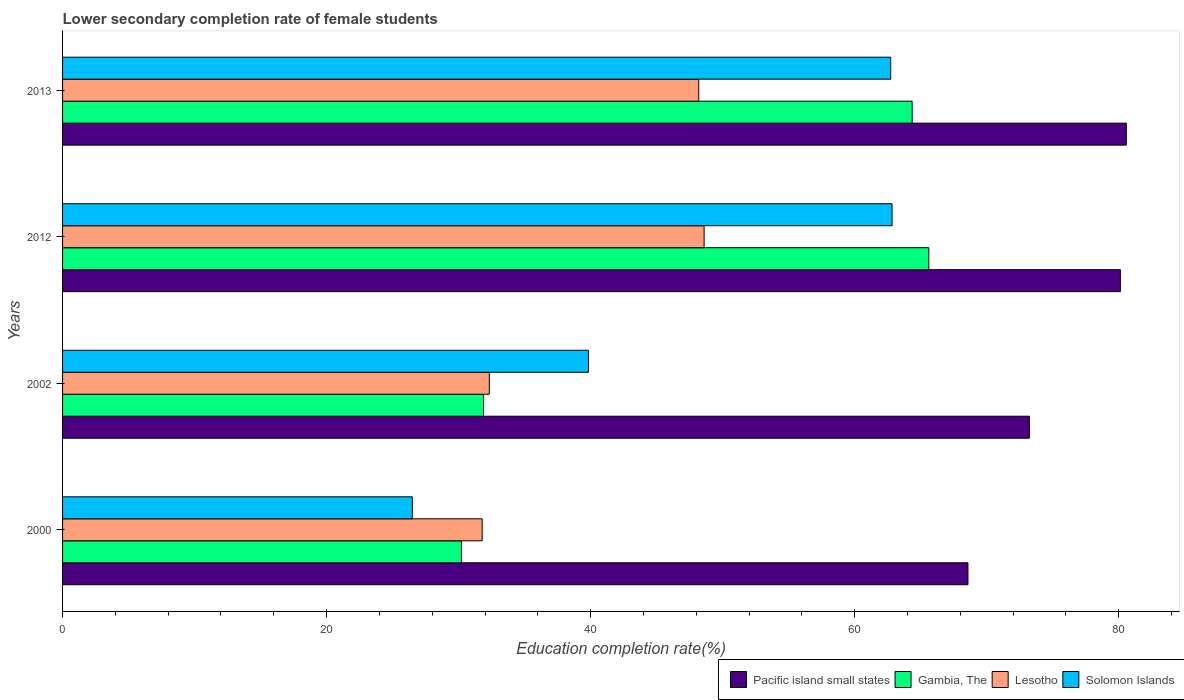How many different coloured bars are there?
Provide a succinct answer. 4. How many groups of bars are there?
Provide a short and direct response. 4. Are the number of bars on each tick of the Y-axis equal?
Offer a very short reply. Yes. How many bars are there on the 3rd tick from the top?
Offer a terse response. 4. How many bars are there on the 1st tick from the bottom?
Your response must be concise. 4. In how many cases, is the number of bars for a given year not equal to the number of legend labels?
Make the answer very short. 0. What is the lower secondary completion rate of female students in Gambia, The in 2012?
Give a very brief answer. 65.62. Across all years, what is the maximum lower secondary completion rate of female students in Pacific island small states?
Ensure brevity in your answer.  80.58. Across all years, what is the minimum lower secondary completion rate of female students in Solomon Islands?
Your answer should be compact. 26.5. In which year was the lower secondary completion rate of female students in Lesotho minimum?
Give a very brief answer. 2000. What is the total lower secondary completion rate of female students in Lesotho in the graph?
Your answer should be very brief. 160.9. What is the difference between the lower secondary completion rate of female students in Lesotho in 2000 and that in 2013?
Offer a very short reply. -16.4. What is the difference between the lower secondary completion rate of female students in Lesotho in 2012 and the lower secondary completion rate of female students in Gambia, The in 2002?
Offer a very short reply. 16.71. What is the average lower secondary completion rate of female students in Gambia, The per year?
Make the answer very short. 48.02. In the year 2012, what is the difference between the lower secondary completion rate of female students in Solomon Islands and lower secondary completion rate of female students in Pacific island small states?
Make the answer very short. -17.3. In how many years, is the lower secondary completion rate of female students in Pacific island small states greater than 56 %?
Offer a very short reply. 4. What is the ratio of the lower secondary completion rate of female students in Lesotho in 2000 to that in 2002?
Give a very brief answer. 0.98. What is the difference between the highest and the second highest lower secondary completion rate of female students in Lesotho?
Offer a terse response. 0.41. What is the difference between the highest and the lowest lower secondary completion rate of female students in Lesotho?
Give a very brief answer. 16.81. Is it the case that in every year, the sum of the lower secondary completion rate of female students in Gambia, The and lower secondary completion rate of female students in Pacific island small states is greater than the sum of lower secondary completion rate of female students in Lesotho and lower secondary completion rate of female students in Solomon Islands?
Keep it short and to the point. No. What does the 1st bar from the top in 2000 represents?
Your answer should be very brief. Solomon Islands. What does the 2nd bar from the bottom in 2013 represents?
Provide a short and direct response. Gambia, The. How many bars are there?
Your answer should be very brief. 16. Are all the bars in the graph horizontal?
Offer a very short reply. Yes. How many years are there in the graph?
Keep it short and to the point. 4. Does the graph contain any zero values?
Provide a short and direct response. No. Does the graph contain grids?
Provide a short and direct response. No. Where does the legend appear in the graph?
Your answer should be very brief. Bottom right. How are the legend labels stacked?
Keep it short and to the point. Horizontal. What is the title of the graph?
Your answer should be compact. Lower secondary completion rate of female students. What is the label or title of the X-axis?
Your response must be concise. Education completion rate(%). What is the label or title of the Y-axis?
Your answer should be very brief. Years. What is the Education completion rate(%) of Pacific island small states in 2000?
Give a very brief answer. 68.58. What is the Education completion rate(%) in Gambia, The in 2000?
Ensure brevity in your answer.  30.21. What is the Education completion rate(%) of Lesotho in 2000?
Provide a succinct answer. 31.79. What is the Education completion rate(%) of Solomon Islands in 2000?
Provide a short and direct response. 26.5. What is the Education completion rate(%) of Pacific island small states in 2002?
Your answer should be very brief. 73.24. What is the Education completion rate(%) in Gambia, The in 2002?
Keep it short and to the point. 31.89. What is the Education completion rate(%) of Lesotho in 2002?
Offer a very short reply. 32.33. What is the Education completion rate(%) in Solomon Islands in 2002?
Offer a very short reply. 39.83. What is the Education completion rate(%) of Pacific island small states in 2012?
Offer a terse response. 80.13. What is the Education completion rate(%) in Gambia, The in 2012?
Give a very brief answer. 65.62. What is the Education completion rate(%) in Lesotho in 2012?
Provide a succinct answer. 48.6. What is the Education completion rate(%) of Solomon Islands in 2012?
Your response must be concise. 62.83. What is the Education completion rate(%) in Pacific island small states in 2013?
Provide a short and direct response. 80.58. What is the Education completion rate(%) in Gambia, The in 2013?
Provide a short and direct response. 64.35. What is the Education completion rate(%) in Lesotho in 2013?
Keep it short and to the point. 48.19. What is the Education completion rate(%) of Solomon Islands in 2013?
Make the answer very short. 62.73. Across all years, what is the maximum Education completion rate(%) in Pacific island small states?
Give a very brief answer. 80.58. Across all years, what is the maximum Education completion rate(%) in Gambia, The?
Your answer should be very brief. 65.62. Across all years, what is the maximum Education completion rate(%) of Lesotho?
Keep it short and to the point. 48.6. Across all years, what is the maximum Education completion rate(%) in Solomon Islands?
Your response must be concise. 62.83. Across all years, what is the minimum Education completion rate(%) in Pacific island small states?
Your answer should be very brief. 68.58. Across all years, what is the minimum Education completion rate(%) in Gambia, The?
Your answer should be compact. 30.21. Across all years, what is the minimum Education completion rate(%) in Lesotho?
Your response must be concise. 31.79. Across all years, what is the minimum Education completion rate(%) of Solomon Islands?
Your response must be concise. 26.5. What is the total Education completion rate(%) of Pacific island small states in the graph?
Your response must be concise. 302.53. What is the total Education completion rate(%) in Gambia, The in the graph?
Give a very brief answer. 192.08. What is the total Education completion rate(%) in Lesotho in the graph?
Ensure brevity in your answer.  160.9. What is the total Education completion rate(%) in Solomon Islands in the graph?
Your answer should be very brief. 191.89. What is the difference between the Education completion rate(%) of Pacific island small states in 2000 and that in 2002?
Your response must be concise. -4.65. What is the difference between the Education completion rate(%) in Gambia, The in 2000 and that in 2002?
Offer a very short reply. -1.68. What is the difference between the Education completion rate(%) of Lesotho in 2000 and that in 2002?
Keep it short and to the point. -0.54. What is the difference between the Education completion rate(%) in Solomon Islands in 2000 and that in 2002?
Give a very brief answer. -13.34. What is the difference between the Education completion rate(%) in Pacific island small states in 2000 and that in 2012?
Keep it short and to the point. -11.54. What is the difference between the Education completion rate(%) of Gambia, The in 2000 and that in 2012?
Keep it short and to the point. -35.4. What is the difference between the Education completion rate(%) in Lesotho in 2000 and that in 2012?
Give a very brief answer. -16.81. What is the difference between the Education completion rate(%) of Solomon Islands in 2000 and that in 2012?
Make the answer very short. -36.34. What is the difference between the Education completion rate(%) of Pacific island small states in 2000 and that in 2013?
Give a very brief answer. -11.99. What is the difference between the Education completion rate(%) in Gambia, The in 2000 and that in 2013?
Make the answer very short. -34.14. What is the difference between the Education completion rate(%) in Lesotho in 2000 and that in 2013?
Ensure brevity in your answer.  -16.4. What is the difference between the Education completion rate(%) in Solomon Islands in 2000 and that in 2013?
Your response must be concise. -36.24. What is the difference between the Education completion rate(%) in Pacific island small states in 2002 and that in 2012?
Make the answer very short. -6.89. What is the difference between the Education completion rate(%) of Gambia, The in 2002 and that in 2012?
Offer a very short reply. -33.73. What is the difference between the Education completion rate(%) in Lesotho in 2002 and that in 2012?
Provide a short and direct response. -16.27. What is the difference between the Education completion rate(%) in Solomon Islands in 2002 and that in 2012?
Ensure brevity in your answer.  -23. What is the difference between the Education completion rate(%) in Pacific island small states in 2002 and that in 2013?
Your answer should be compact. -7.34. What is the difference between the Education completion rate(%) in Gambia, The in 2002 and that in 2013?
Ensure brevity in your answer.  -32.46. What is the difference between the Education completion rate(%) of Lesotho in 2002 and that in 2013?
Give a very brief answer. -15.86. What is the difference between the Education completion rate(%) in Solomon Islands in 2002 and that in 2013?
Your response must be concise. -22.9. What is the difference between the Education completion rate(%) in Pacific island small states in 2012 and that in 2013?
Provide a succinct answer. -0.45. What is the difference between the Education completion rate(%) in Gambia, The in 2012 and that in 2013?
Provide a succinct answer. 1.26. What is the difference between the Education completion rate(%) of Lesotho in 2012 and that in 2013?
Your response must be concise. 0.41. What is the difference between the Education completion rate(%) in Solomon Islands in 2012 and that in 2013?
Ensure brevity in your answer.  0.1. What is the difference between the Education completion rate(%) in Pacific island small states in 2000 and the Education completion rate(%) in Gambia, The in 2002?
Your answer should be compact. 36.69. What is the difference between the Education completion rate(%) in Pacific island small states in 2000 and the Education completion rate(%) in Lesotho in 2002?
Ensure brevity in your answer.  36.26. What is the difference between the Education completion rate(%) of Pacific island small states in 2000 and the Education completion rate(%) of Solomon Islands in 2002?
Provide a short and direct response. 28.75. What is the difference between the Education completion rate(%) of Gambia, The in 2000 and the Education completion rate(%) of Lesotho in 2002?
Give a very brief answer. -2.11. What is the difference between the Education completion rate(%) of Gambia, The in 2000 and the Education completion rate(%) of Solomon Islands in 2002?
Provide a short and direct response. -9.62. What is the difference between the Education completion rate(%) of Lesotho in 2000 and the Education completion rate(%) of Solomon Islands in 2002?
Offer a very short reply. -8.05. What is the difference between the Education completion rate(%) of Pacific island small states in 2000 and the Education completion rate(%) of Gambia, The in 2012?
Provide a succinct answer. 2.97. What is the difference between the Education completion rate(%) of Pacific island small states in 2000 and the Education completion rate(%) of Lesotho in 2012?
Offer a very short reply. 19.99. What is the difference between the Education completion rate(%) of Pacific island small states in 2000 and the Education completion rate(%) of Solomon Islands in 2012?
Keep it short and to the point. 5.75. What is the difference between the Education completion rate(%) of Gambia, The in 2000 and the Education completion rate(%) of Lesotho in 2012?
Offer a terse response. -18.38. What is the difference between the Education completion rate(%) in Gambia, The in 2000 and the Education completion rate(%) in Solomon Islands in 2012?
Keep it short and to the point. -32.62. What is the difference between the Education completion rate(%) in Lesotho in 2000 and the Education completion rate(%) in Solomon Islands in 2012?
Ensure brevity in your answer.  -31.05. What is the difference between the Education completion rate(%) in Pacific island small states in 2000 and the Education completion rate(%) in Gambia, The in 2013?
Give a very brief answer. 4.23. What is the difference between the Education completion rate(%) in Pacific island small states in 2000 and the Education completion rate(%) in Lesotho in 2013?
Make the answer very short. 20.39. What is the difference between the Education completion rate(%) of Pacific island small states in 2000 and the Education completion rate(%) of Solomon Islands in 2013?
Ensure brevity in your answer.  5.85. What is the difference between the Education completion rate(%) of Gambia, The in 2000 and the Education completion rate(%) of Lesotho in 2013?
Provide a short and direct response. -17.97. What is the difference between the Education completion rate(%) of Gambia, The in 2000 and the Education completion rate(%) of Solomon Islands in 2013?
Provide a succinct answer. -32.52. What is the difference between the Education completion rate(%) in Lesotho in 2000 and the Education completion rate(%) in Solomon Islands in 2013?
Give a very brief answer. -30.95. What is the difference between the Education completion rate(%) in Pacific island small states in 2002 and the Education completion rate(%) in Gambia, The in 2012?
Offer a very short reply. 7.62. What is the difference between the Education completion rate(%) of Pacific island small states in 2002 and the Education completion rate(%) of Lesotho in 2012?
Keep it short and to the point. 24.64. What is the difference between the Education completion rate(%) in Pacific island small states in 2002 and the Education completion rate(%) in Solomon Islands in 2012?
Keep it short and to the point. 10.4. What is the difference between the Education completion rate(%) in Gambia, The in 2002 and the Education completion rate(%) in Lesotho in 2012?
Your answer should be compact. -16.71. What is the difference between the Education completion rate(%) of Gambia, The in 2002 and the Education completion rate(%) of Solomon Islands in 2012?
Offer a terse response. -30.94. What is the difference between the Education completion rate(%) of Lesotho in 2002 and the Education completion rate(%) of Solomon Islands in 2012?
Give a very brief answer. -30.5. What is the difference between the Education completion rate(%) of Pacific island small states in 2002 and the Education completion rate(%) of Gambia, The in 2013?
Keep it short and to the point. 8.88. What is the difference between the Education completion rate(%) of Pacific island small states in 2002 and the Education completion rate(%) of Lesotho in 2013?
Offer a terse response. 25.05. What is the difference between the Education completion rate(%) in Pacific island small states in 2002 and the Education completion rate(%) in Solomon Islands in 2013?
Give a very brief answer. 10.5. What is the difference between the Education completion rate(%) in Gambia, The in 2002 and the Education completion rate(%) in Lesotho in 2013?
Offer a very short reply. -16.3. What is the difference between the Education completion rate(%) in Gambia, The in 2002 and the Education completion rate(%) in Solomon Islands in 2013?
Keep it short and to the point. -30.84. What is the difference between the Education completion rate(%) in Lesotho in 2002 and the Education completion rate(%) in Solomon Islands in 2013?
Keep it short and to the point. -30.4. What is the difference between the Education completion rate(%) of Pacific island small states in 2012 and the Education completion rate(%) of Gambia, The in 2013?
Your response must be concise. 15.77. What is the difference between the Education completion rate(%) in Pacific island small states in 2012 and the Education completion rate(%) in Lesotho in 2013?
Give a very brief answer. 31.94. What is the difference between the Education completion rate(%) of Pacific island small states in 2012 and the Education completion rate(%) of Solomon Islands in 2013?
Offer a very short reply. 17.4. What is the difference between the Education completion rate(%) in Gambia, The in 2012 and the Education completion rate(%) in Lesotho in 2013?
Provide a succinct answer. 17.43. What is the difference between the Education completion rate(%) of Gambia, The in 2012 and the Education completion rate(%) of Solomon Islands in 2013?
Ensure brevity in your answer.  2.89. What is the difference between the Education completion rate(%) of Lesotho in 2012 and the Education completion rate(%) of Solomon Islands in 2013?
Provide a succinct answer. -14.13. What is the average Education completion rate(%) of Pacific island small states per year?
Your response must be concise. 75.63. What is the average Education completion rate(%) of Gambia, The per year?
Your answer should be very brief. 48.02. What is the average Education completion rate(%) in Lesotho per year?
Your response must be concise. 40.22. What is the average Education completion rate(%) in Solomon Islands per year?
Give a very brief answer. 47.97. In the year 2000, what is the difference between the Education completion rate(%) of Pacific island small states and Education completion rate(%) of Gambia, The?
Offer a terse response. 38.37. In the year 2000, what is the difference between the Education completion rate(%) of Pacific island small states and Education completion rate(%) of Lesotho?
Make the answer very short. 36.8. In the year 2000, what is the difference between the Education completion rate(%) of Pacific island small states and Education completion rate(%) of Solomon Islands?
Make the answer very short. 42.09. In the year 2000, what is the difference between the Education completion rate(%) in Gambia, The and Education completion rate(%) in Lesotho?
Give a very brief answer. -1.57. In the year 2000, what is the difference between the Education completion rate(%) of Gambia, The and Education completion rate(%) of Solomon Islands?
Ensure brevity in your answer.  3.72. In the year 2000, what is the difference between the Education completion rate(%) of Lesotho and Education completion rate(%) of Solomon Islands?
Give a very brief answer. 5.29. In the year 2002, what is the difference between the Education completion rate(%) of Pacific island small states and Education completion rate(%) of Gambia, The?
Offer a terse response. 41.34. In the year 2002, what is the difference between the Education completion rate(%) of Pacific island small states and Education completion rate(%) of Lesotho?
Give a very brief answer. 40.91. In the year 2002, what is the difference between the Education completion rate(%) of Pacific island small states and Education completion rate(%) of Solomon Islands?
Provide a succinct answer. 33.4. In the year 2002, what is the difference between the Education completion rate(%) of Gambia, The and Education completion rate(%) of Lesotho?
Keep it short and to the point. -0.44. In the year 2002, what is the difference between the Education completion rate(%) in Gambia, The and Education completion rate(%) in Solomon Islands?
Give a very brief answer. -7.94. In the year 2002, what is the difference between the Education completion rate(%) in Lesotho and Education completion rate(%) in Solomon Islands?
Your response must be concise. -7.51. In the year 2012, what is the difference between the Education completion rate(%) of Pacific island small states and Education completion rate(%) of Gambia, The?
Your answer should be compact. 14.51. In the year 2012, what is the difference between the Education completion rate(%) of Pacific island small states and Education completion rate(%) of Lesotho?
Your response must be concise. 31.53. In the year 2012, what is the difference between the Education completion rate(%) of Pacific island small states and Education completion rate(%) of Solomon Islands?
Offer a very short reply. 17.3. In the year 2012, what is the difference between the Education completion rate(%) in Gambia, The and Education completion rate(%) in Lesotho?
Provide a short and direct response. 17.02. In the year 2012, what is the difference between the Education completion rate(%) of Gambia, The and Education completion rate(%) of Solomon Islands?
Keep it short and to the point. 2.78. In the year 2012, what is the difference between the Education completion rate(%) in Lesotho and Education completion rate(%) in Solomon Islands?
Provide a succinct answer. -14.24. In the year 2013, what is the difference between the Education completion rate(%) of Pacific island small states and Education completion rate(%) of Gambia, The?
Your answer should be very brief. 16.22. In the year 2013, what is the difference between the Education completion rate(%) in Pacific island small states and Education completion rate(%) in Lesotho?
Give a very brief answer. 32.39. In the year 2013, what is the difference between the Education completion rate(%) of Pacific island small states and Education completion rate(%) of Solomon Islands?
Keep it short and to the point. 17.85. In the year 2013, what is the difference between the Education completion rate(%) in Gambia, The and Education completion rate(%) in Lesotho?
Ensure brevity in your answer.  16.17. In the year 2013, what is the difference between the Education completion rate(%) of Gambia, The and Education completion rate(%) of Solomon Islands?
Offer a terse response. 1.62. In the year 2013, what is the difference between the Education completion rate(%) in Lesotho and Education completion rate(%) in Solomon Islands?
Keep it short and to the point. -14.54. What is the ratio of the Education completion rate(%) of Pacific island small states in 2000 to that in 2002?
Give a very brief answer. 0.94. What is the ratio of the Education completion rate(%) in Lesotho in 2000 to that in 2002?
Give a very brief answer. 0.98. What is the ratio of the Education completion rate(%) in Solomon Islands in 2000 to that in 2002?
Offer a very short reply. 0.67. What is the ratio of the Education completion rate(%) of Pacific island small states in 2000 to that in 2012?
Offer a terse response. 0.86. What is the ratio of the Education completion rate(%) in Gambia, The in 2000 to that in 2012?
Keep it short and to the point. 0.46. What is the ratio of the Education completion rate(%) in Lesotho in 2000 to that in 2012?
Offer a terse response. 0.65. What is the ratio of the Education completion rate(%) of Solomon Islands in 2000 to that in 2012?
Make the answer very short. 0.42. What is the ratio of the Education completion rate(%) in Pacific island small states in 2000 to that in 2013?
Give a very brief answer. 0.85. What is the ratio of the Education completion rate(%) in Gambia, The in 2000 to that in 2013?
Make the answer very short. 0.47. What is the ratio of the Education completion rate(%) of Lesotho in 2000 to that in 2013?
Offer a terse response. 0.66. What is the ratio of the Education completion rate(%) of Solomon Islands in 2000 to that in 2013?
Make the answer very short. 0.42. What is the ratio of the Education completion rate(%) in Pacific island small states in 2002 to that in 2012?
Your answer should be very brief. 0.91. What is the ratio of the Education completion rate(%) of Gambia, The in 2002 to that in 2012?
Make the answer very short. 0.49. What is the ratio of the Education completion rate(%) of Lesotho in 2002 to that in 2012?
Your answer should be compact. 0.67. What is the ratio of the Education completion rate(%) in Solomon Islands in 2002 to that in 2012?
Keep it short and to the point. 0.63. What is the ratio of the Education completion rate(%) of Pacific island small states in 2002 to that in 2013?
Keep it short and to the point. 0.91. What is the ratio of the Education completion rate(%) of Gambia, The in 2002 to that in 2013?
Provide a short and direct response. 0.5. What is the ratio of the Education completion rate(%) in Lesotho in 2002 to that in 2013?
Provide a short and direct response. 0.67. What is the ratio of the Education completion rate(%) in Solomon Islands in 2002 to that in 2013?
Provide a succinct answer. 0.64. What is the ratio of the Education completion rate(%) of Gambia, The in 2012 to that in 2013?
Offer a very short reply. 1.02. What is the ratio of the Education completion rate(%) of Lesotho in 2012 to that in 2013?
Give a very brief answer. 1.01. What is the ratio of the Education completion rate(%) of Solomon Islands in 2012 to that in 2013?
Ensure brevity in your answer.  1. What is the difference between the highest and the second highest Education completion rate(%) of Pacific island small states?
Your answer should be compact. 0.45. What is the difference between the highest and the second highest Education completion rate(%) in Gambia, The?
Offer a very short reply. 1.26. What is the difference between the highest and the second highest Education completion rate(%) in Lesotho?
Offer a very short reply. 0.41. What is the difference between the highest and the second highest Education completion rate(%) in Solomon Islands?
Keep it short and to the point. 0.1. What is the difference between the highest and the lowest Education completion rate(%) of Pacific island small states?
Provide a short and direct response. 11.99. What is the difference between the highest and the lowest Education completion rate(%) of Gambia, The?
Your answer should be very brief. 35.4. What is the difference between the highest and the lowest Education completion rate(%) of Lesotho?
Your answer should be compact. 16.81. What is the difference between the highest and the lowest Education completion rate(%) in Solomon Islands?
Keep it short and to the point. 36.34. 